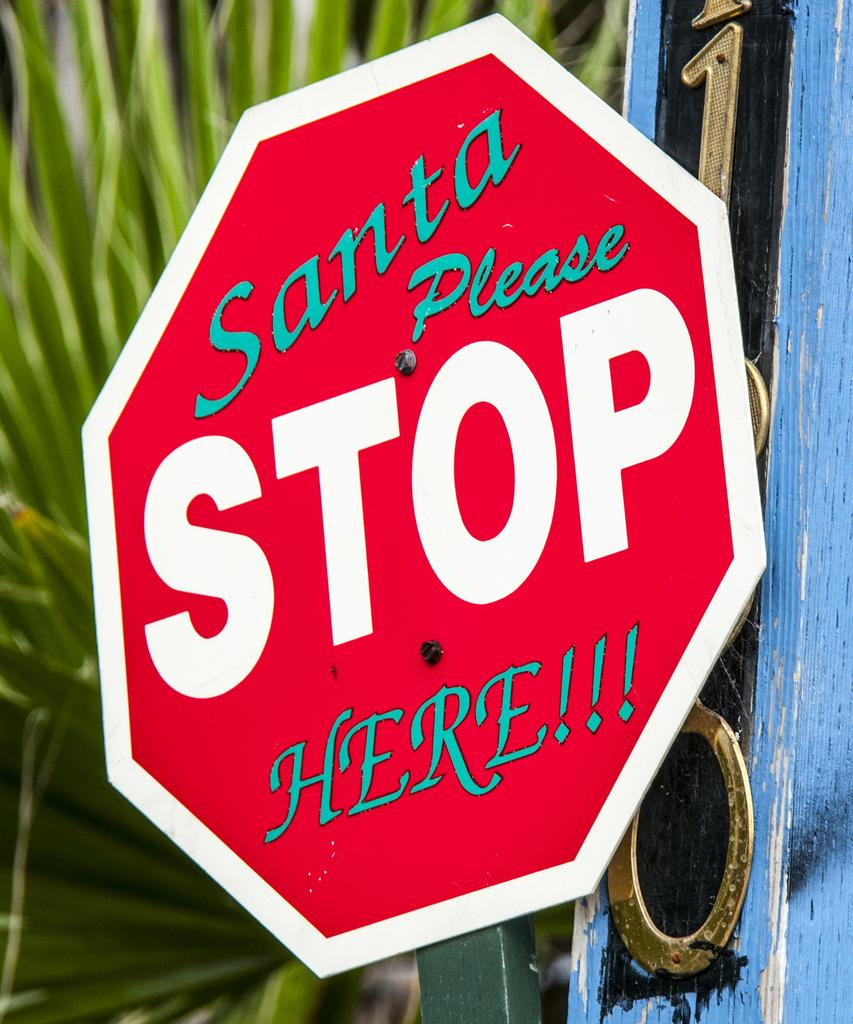Provide a one-sentence caption for the provided image. a Stop Here Santa sign that was edited that way. 